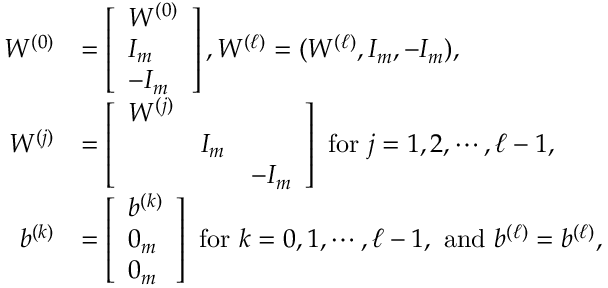Convert formula to latex. <formula><loc_0><loc_0><loc_500><loc_500>\begin{array} { r l } { W ^ { ( 0 ) } } & { = \left [ \begin{array} { l } { W ^ { ( 0 ) } } \\ { I _ { m } } \\ { - I _ { m } } \end{array} \right ] , W ^ { ( \ell ) } = ( W ^ { ( \ell ) } , I _ { m } , - I _ { m } ) , } \\ { W ^ { ( j ) } } & { = \left [ \begin{array} { l l l } { W ^ { ( j ) } } & & \\ & { I _ { m } } & \\ & & { - I _ { m } } \end{array} \right ] f o r j = 1 , 2 , \cdots , \ell - 1 , } \\ { b ^ { ( k ) } } & { = \left [ \begin{array} { l } { b ^ { ( k ) } } \\ { 0 _ { m } } \\ { 0 _ { m } } \end{array} \right ] f o r k = 0 , 1 , \cdots , \ell - 1 , a n d b ^ { ( \ell ) } = b ^ { ( \ell ) } , } \end{array}</formula> 